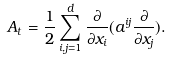<formula> <loc_0><loc_0><loc_500><loc_500>A _ { t } = \frac { 1 } { 2 } \sum _ { i , j = 1 } ^ { d } \frac { \partial } { \partial x _ { i } } ( a ^ { i j } \frac { \partial } { \partial x _ { j } } ) .</formula> 